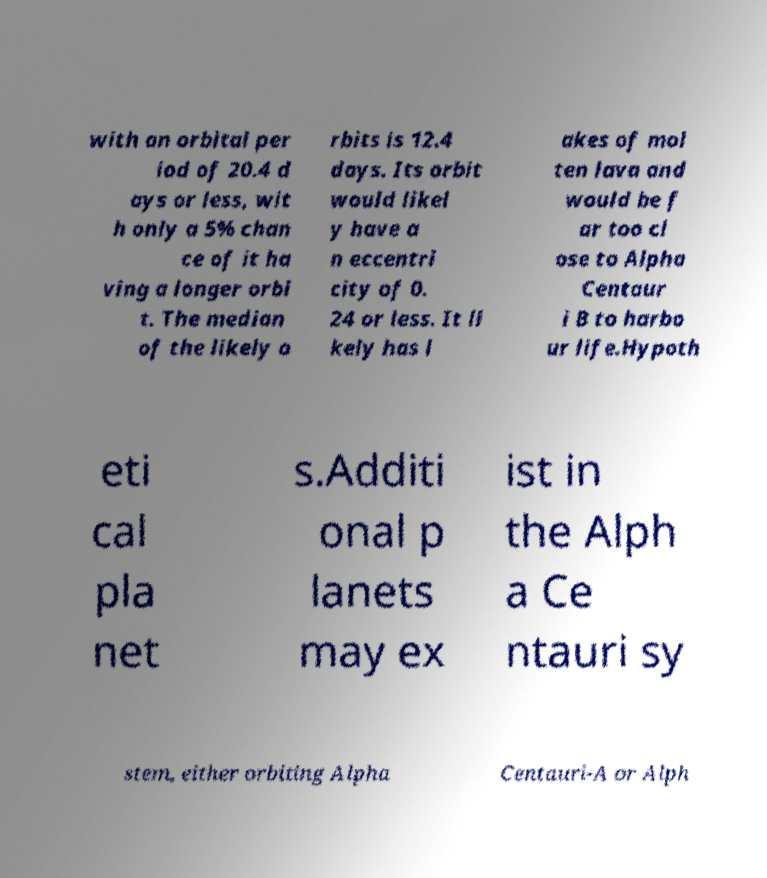Can you read and provide the text displayed in the image?This photo seems to have some interesting text. Can you extract and type it out for me? with an orbital per iod of 20.4 d ays or less, wit h only a 5% chan ce of it ha ving a longer orbi t. The median of the likely o rbits is 12.4 days. Its orbit would likel y have a n eccentri city of 0. 24 or less. It li kely has l akes of mol ten lava and would be f ar too cl ose to Alpha Centaur i B to harbo ur life.Hypoth eti cal pla net s.Additi onal p lanets may ex ist in the Alph a Ce ntauri sy stem, either orbiting Alpha Centauri-A or Alph 